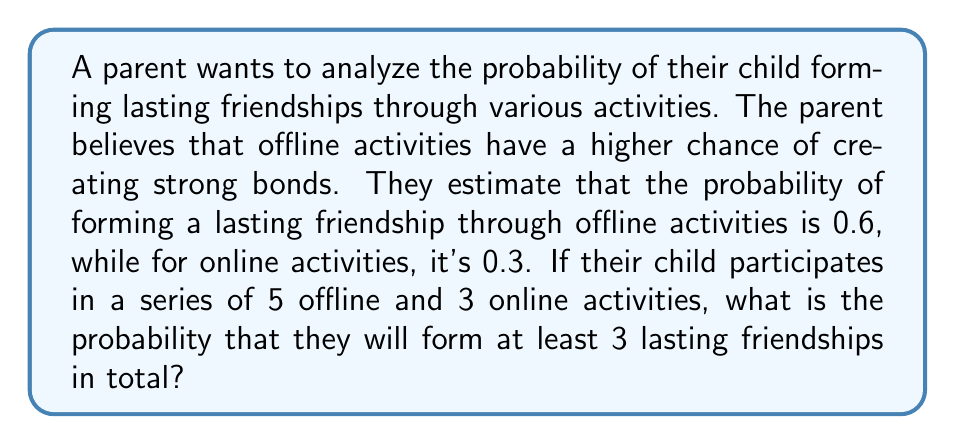Can you solve this math problem? Let's approach this step-by-step using the concept of binomial probability and the addition rule of probability.

1) First, we need to calculate the probability of forming exactly 3, 4, 5, 6, 7, or 8 lasting friendships.

2) Let's define our events:
   A: Forming a lasting friendship in an offline activity (p = 0.6)
   B: Forming a lasting friendship in an online activity (p = 0.3)

3) We can use the binomial probability formula for each possible outcome:

   $P(X = k) = \binom{n}{k} p^k (1-p)^{n-k}$

   Where n is the number of trials, k is the number of successes, and p is the probability of success on each trial.

4) For offline activities (n = 5):
   $P(X = i) = \binom{5}{i} (0.6)^i (0.4)^{5-i}$ for i = 0, 1, 2, 3, 4, 5

5) For online activities (n = 3):
   $P(Y = j) = \binom{3}{j} (0.3)^j (0.7)^{3-j}$ for j = 0, 1, 2, 3

6) Now, we need to sum the probabilities of all combinations where i + j ≥ 3:

   $P(Total \geq 3) = \sum_{i=0}^5 \sum_{j=0}^3 P(X=i) \cdot P(Y=j)$ for i + j ≥ 3

7) Calculating this sum:

   $P(Total \geq 3) = P(3,0) + P(3,1) + P(3,2) + P(3,3) +$
                    $P(4,0) + P(4,1) + P(4,2) + P(4,3) +$
                    $P(5,0) + P(5,1) + P(5,2) + P(5,3)$

   Where P(i,j) is the probability of i successes in offline activities and j successes in online activities.

8) Computing these probabilities and summing them up:

   $P(Total \geq 3) = 0.3456 + 0.1482 + 0.0212 + 0.0010 +$
                    $0.2592 + 0.1111 + 0.0159 + 0.0008 +$
                    $0.0778 + 0.0333 + 0.0048 + 0.0002$
                  $= 0.9191$
Answer: The probability of forming at least 3 lasting friendships is approximately 0.9191 or 91.91%. 